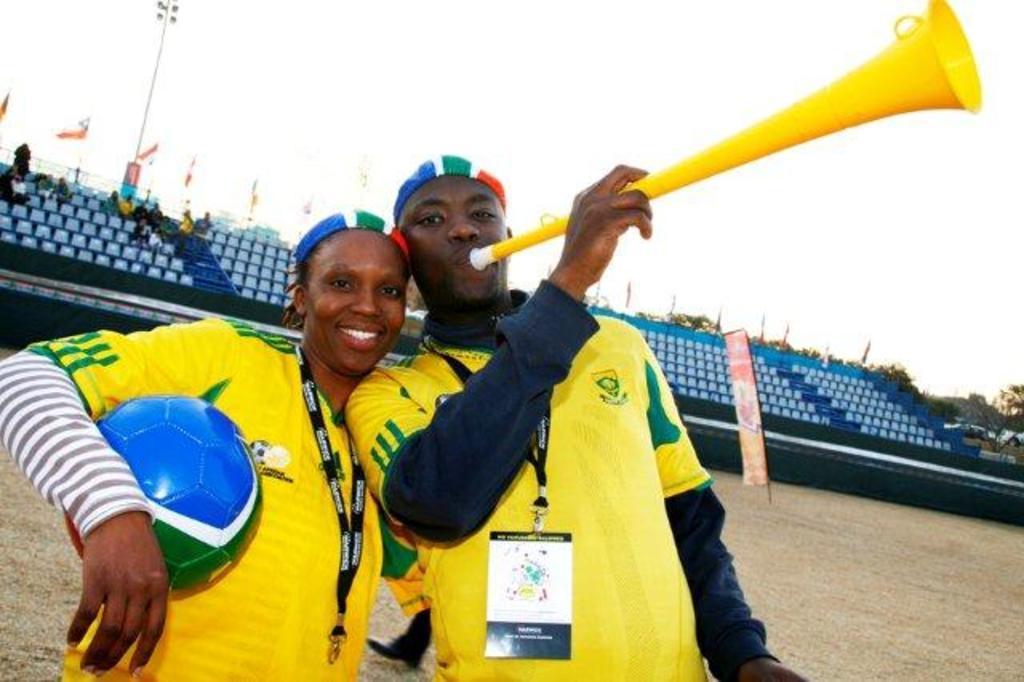Please provide a concise description of this image. In the image we can see a man and a woman standing, wearing the same clothes and identity card. The woman is holding a ball and the man is holding a musical instrument. Here it looks like a stadium, here we can see the trees and the light pole, the flags and the sky. 